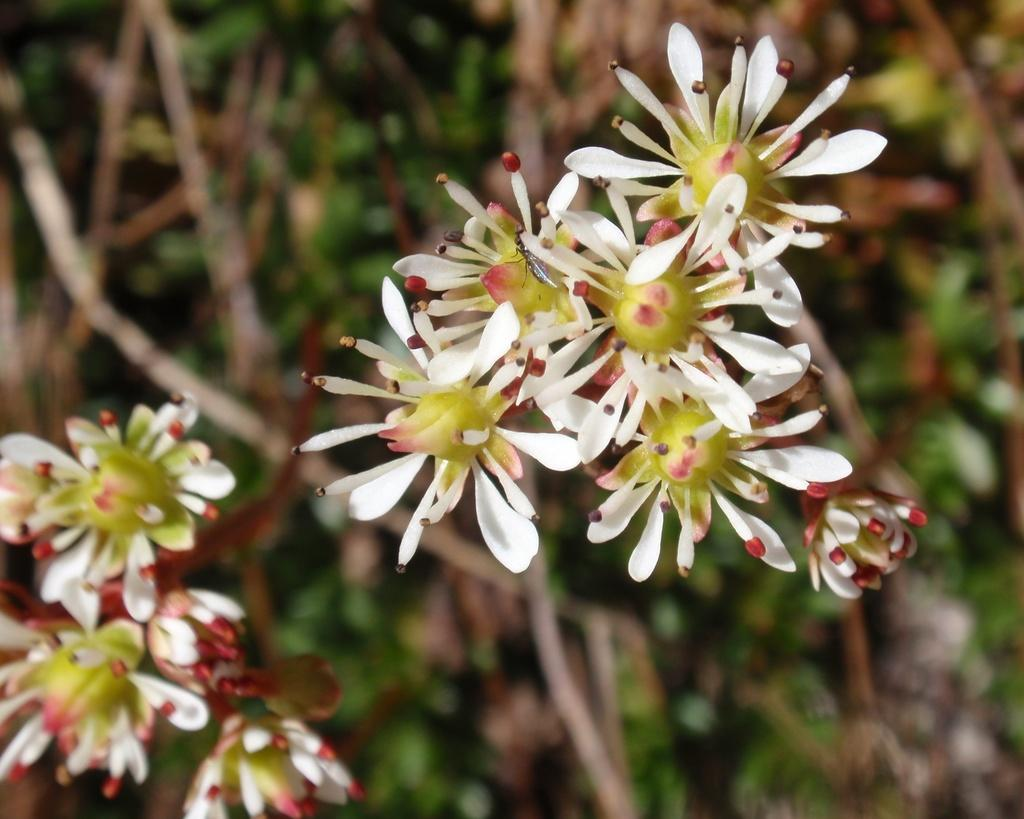What colors are the flowers in the image? The flowers in the image are white and green. Can you describe the flowers in more detail? Unfortunately, the image does not provide enough detail to describe the flowers further. What can be seen in the background of the image? There is a blurred image in the background. How many ducks are swimming in the pond in the image? There are no ducks or ponds present in the image; it features white and green flowers with a blurred background. What song is being sung by the birds in the image? There are no birds or songs present in the image; it features white and green flowers with a blurred background. 